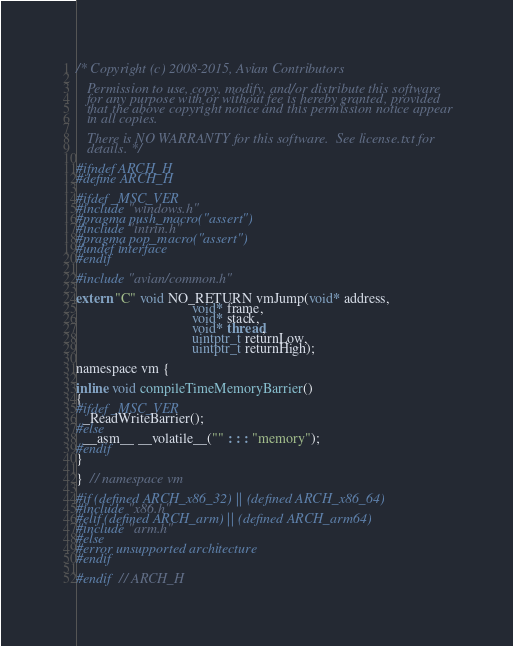Convert code to text. <code><loc_0><loc_0><loc_500><loc_500><_C_>/* Copyright (c) 2008-2015, Avian Contributors

   Permission to use, copy, modify, and/or distribute this software
   for any purpose with or without fee is hereby granted, provided
   that the above copyright notice and this permission notice appear
   in all copies.

   There is NO WARRANTY for this software.  See license.txt for
   details. */

#ifndef ARCH_H
#define ARCH_H

#ifdef _MSC_VER
#include "windows.h"
#pragma push_macro("assert")
#include "intrin.h"
#pragma pop_macro("assert")
#undef interface
#endif

#include "avian/common.h"

extern "C" void NO_RETURN vmJump(void* address,
                                 void* frame,
                                 void* stack,
                                 void* thread,
                                 uintptr_t returnLow,
                                 uintptr_t returnHigh);

namespace vm {

inline void compileTimeMemoryBarrier()
{
#ifdef _MSC_VER
  _ReadWriteBarrier();
#else
  __asm__ __volatile__("" : : : "memory");
#endif
}

}  // namespace vm

#if (defined ARCH_x86_32) || (defined ARCH_x86_64)
#include "x86.h"
#elif (defined ARCH_arm) || (defined ARCH_arm64)
#include "arm.h"
#else
#error unsupported architecture
#endif

#endif  // ARCH_H
</code> 